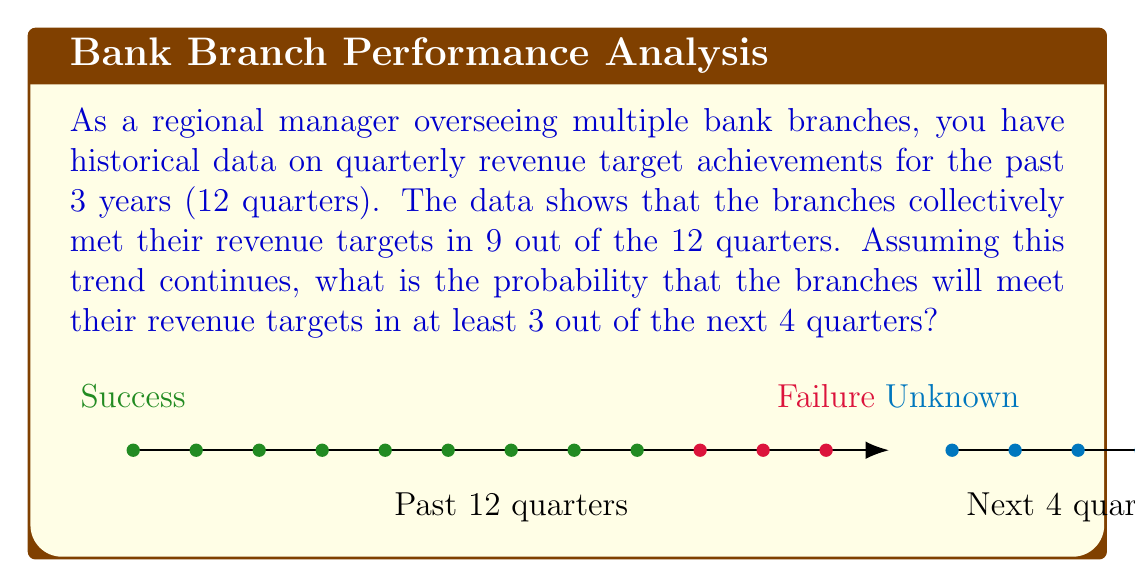Provide a solution to this math problem. Let's approach this step-by-step using the binomial probability distribution:

1) First, we need to calculate the probability of success (meeting the revenue target) in a single quarter based on historical data:
   $$p = \frac{9}{12} = 0.75$$

2) We want to find the probability of at least 3 successes out of 4 trials. This means we need to calculate P(X ≥ 3), where X is the number of successes.

3) We can use the complement of P(X < 3):
   $$P(X \geq 3) = 1 - P(X < 3) = 1 - [P(X=0) + P(X=1) + P(X=2)]$$

4) The binomial probability formula is:
   $$P(X=k) = \binom{n}{k} p^k (1-p)^{n-k}$$
   where n is the number of trials, k is the number of successes, and p is the probability of success on each trial.

5) Let's calculate each probability:
   $$P(X=0) = \binom{4}{0} (0.75)^0 (0.25)^4 = 1 \cdot 1 \cdot 0.00390625 = 0.00390625$$
   $$P(X=1) = \binom{4}{1} (0.75)^1 (0.25)^3 = 4 \cdot 0.75 \cdot 0.015625 = 0.046875$$
   $$P(X=2) = \binom{4}{2} (0.75)^2 (0.25)^2 = 6 \cdot 0.5625 \cdot 0.0625 = 0.2109375$$

6) Now we can sum these probabilities and subtract from 1:
   $$P(X \geq 3) = 1 - (0.00390625 + 0.046875 + 0.2109375) = 1 - 0.26171875 = 0.73828125$$

Therefore, the probability of meeting revenue targets in at least 3 out of the next 4 quarters is approximately 0.7383 or 73.83%.
Answer: 0.7383 (or 73.83%) 